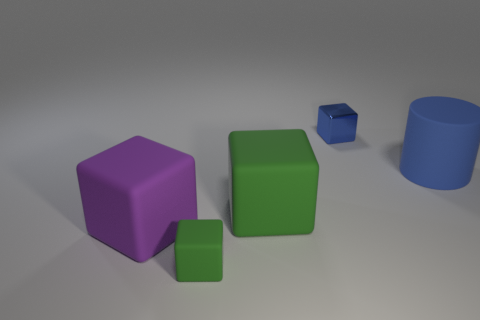How many blue objects are tiny balls or metal blocks?
Keep it short and to the point. 1. What number of other things are there of the same size as the blue cylinder?
Offer a terse response. 2. How many large yellow metal spheres are there?
Provide a short and direct response. 0. Is there any other thing that has the same shape as the big blue matte object?
Provide a succinct answer. No. Are the object that is right of the blue metal cube and the tiny block right of the small green matte block made of the same material?
Provide a short and direct response. No. What material is the tiny blue thing?
Provide a succinct answer. Metal. How many large purple things are the same material as the large green cube?
Your answer should be compact. 1. What number of metallic objects are either green blocks or blue things?
Your answer should be very brief. 1. There is a small thing that is in front of the matte cylinder; is its shape the same as the large matte thing to the right of the blue block?
Your answer should be compact. No. There is a cube that is right of the tiny green object and in front of the big blue cylinder; what color is it?
Make the answer very short. Green. 